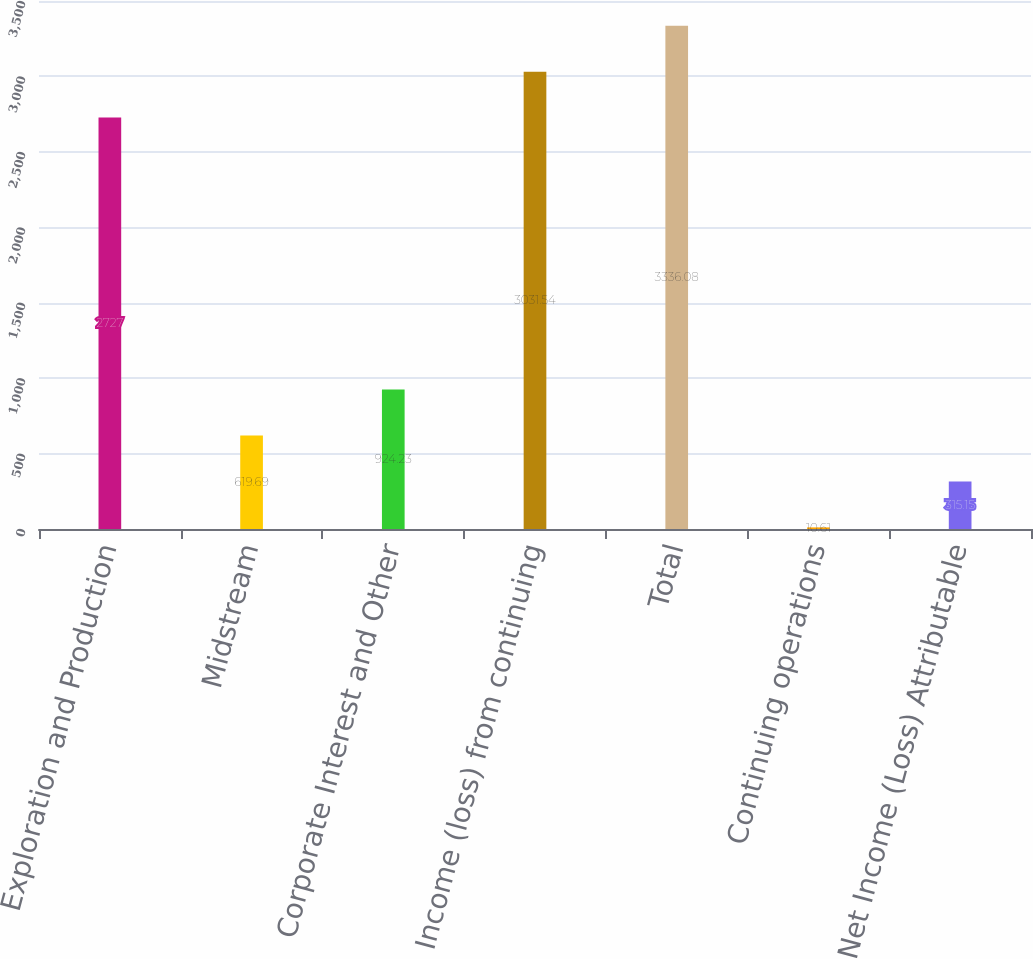<chart> <loc_0><loc_0><loc_500><loc_500><bar_chart><fcel>Exploration and Production<fcel>Midstream<fcel>Corporate Interest and Other<fcel>Income (loss) from continuing<fcel>Total<fcel>Continuing operations<fcel>Net Income (Loss) Attributable<nl><fcel>2727<fcel>619.69<fcel>924.23<fcel>3031.54<fcel>3336.08<fcel>10.61<fcel>315.15<nl></chart> 